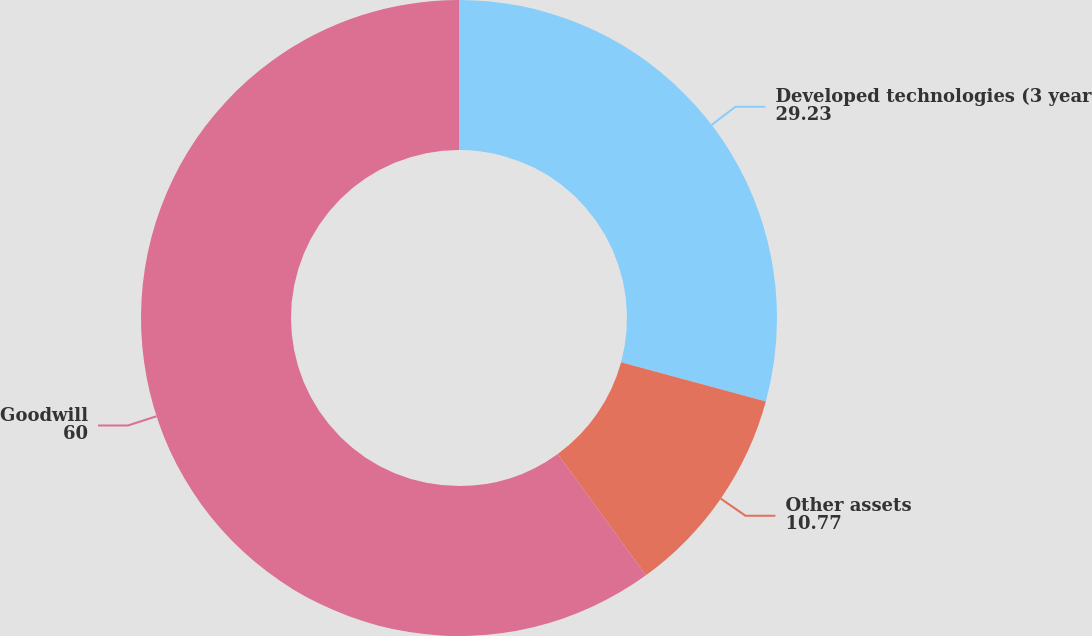Convert chart to OTSL. <chart><loc_0><loc_0><loc_500><loc_500><pie_chart><fcel>Developed technologies (3 year<fcel>Other assets<fcel>Goodwill<nl><fcel>29.23%<fcel>10.77%<fcel>60.0%<nl></chart> 